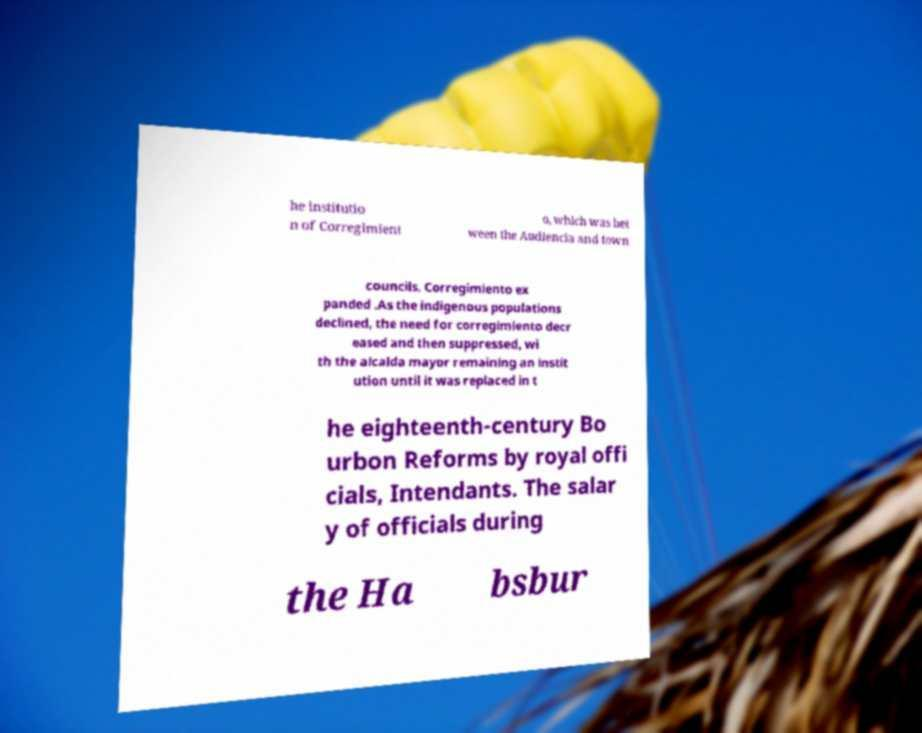For documentation purposes, I need the text within this image transcribed. Could you provide that? he institutio n of Corregimient o, which was bet ween the Audiencia and town councils. Corregimiento ex panded .As the indigenous populations declined, the need for corregimiento decr eased and then suppressed, wi th the alcalda mayor remaining an instit ution until it was replaced in t he eighteenth-century Bo urbon Reforms by royal offi cials, Intendants. The salar y of officials during the Ha bsbur 